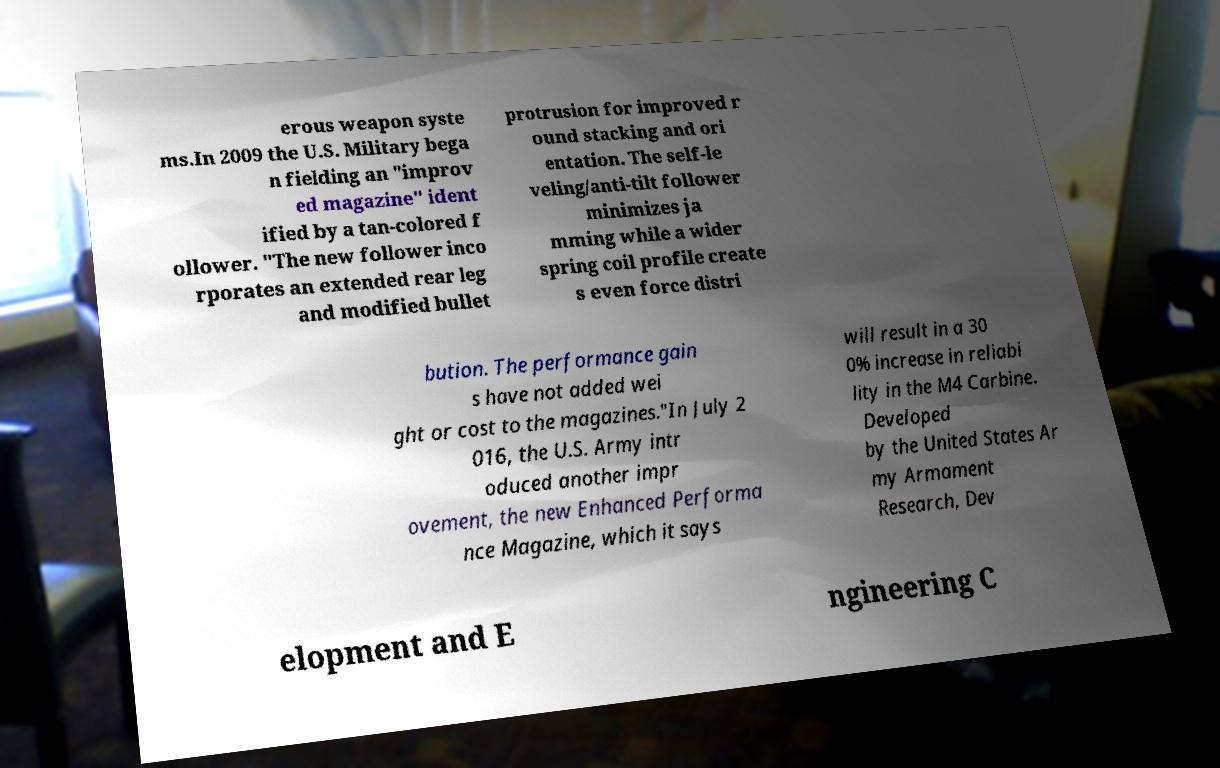Can you read and provide the text displayed in the image?This photo seems to have some interesting text. Can you extract and type it out for me? erous weapon syste ms.In 2009 the U.S. Military bega n fielding an "improv ed magazine" ident ified by a tan-colored f ollower. "The new follower inco rporates an extended rear leg and modified bullet protrusion for improved r ound stacking and ori entation. The self-le veling/anti-tilt follower minimizes ja mming while a wider spring coil profile create s even force distri bution. The performance gain s have not added wei ght or cost to the magazines."In July 2 016, the U.S. Army intr oduced another impr ovement, the new Enhanced Performa nce Magazine, which it says will result in a 30 0% increase in reliabi lity in the M4 Carbine. Developed by the United States Ar my Armament Research, Dev elopment and E ngineering C 